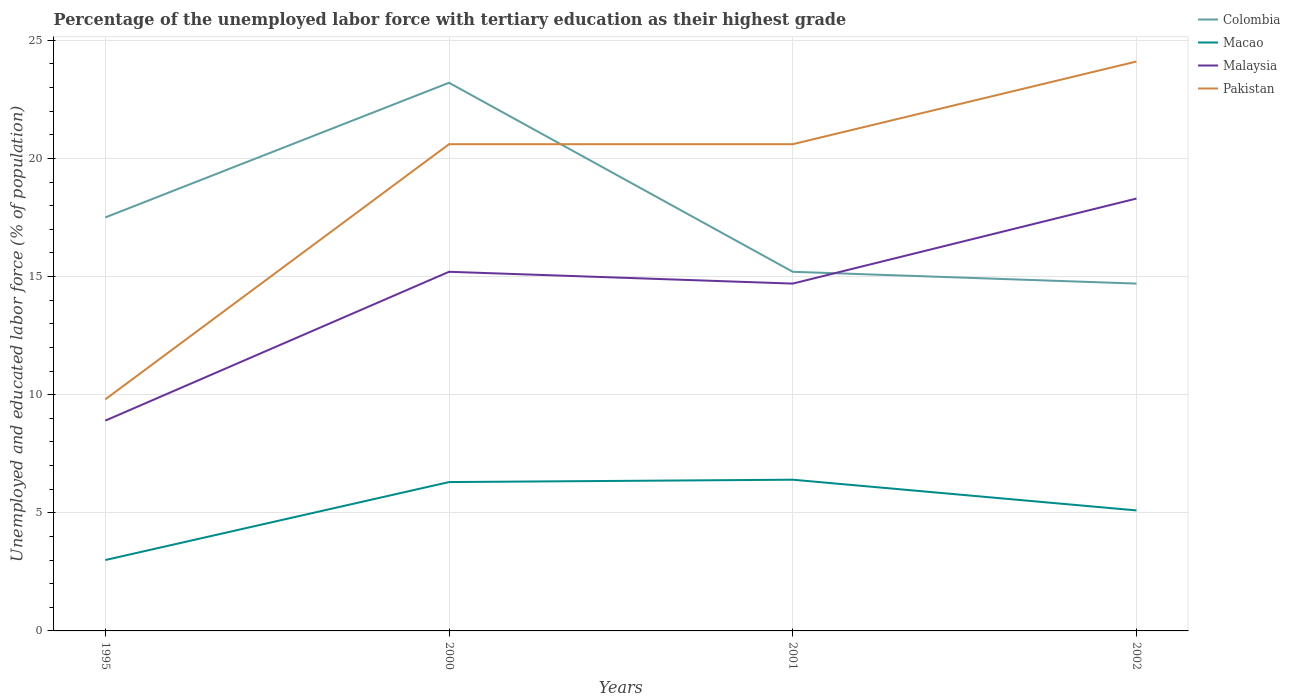Is the number of lines equal to the number of legend labels?
Your answer should be very brief. Yes. Across all years, what is the maximum percentage of the unemployed labor force with tertiary education in Pakistan?
Your response must be concise. 9.8. In which year was the percentage of the unemployed labor force with tertiary education in Macao maximum?
Provide a succinct answer. 1995. What is the total percentage of the unemployed labor force with tertiary education in Colombia in the graph?
Keep it short and to the point. 2.8. What is the difference between the highest and the second highest percentage of the unemployed labor force with tertiary education in Macao?
Ensure brevity in your answer.  3.4. What is the difference between the highest and the lowest percentage of the unemployed labor force with tertiary education in Macao?
Give a very brief answer. 2. Is the percentage of the unemployed labor force with tertiary education in Malaysia strictly greater than the percentage of the unemployed labor force with tertiary education in Macao over the years?
Give a very brief answer. No. How many years are there in the graph?
Your answer should be very brief. 4. What is the difference between two consecutive major ticks on the Y-axis?
Keep it short and to the point. 5. Does the graph contain grids?
Make the answer very short. Yes. How many legend labels are there?
Keep it short and to the point. 4. How are the legend labels stacked?
Your answer should be very brief. Vertical. What is the title of the graph?
Provide a short and direct response. Percentage of the unemployed labor force with tertiary education as their highest grade. Does "Seychelles" appear as one of the legend labels in the graph?
Offer a terse response. No. What is the label or title of the X-axis?
Ensure brevity in your answer.  Years. What is the label or title of the Y-axis?
Your answer should be very brief. Unemployed and educated labor force (% of population). What is the Unemployed and educated labor force (% of population) in Colombia in 1995?
Offer a very short reply. 17.5. What is the Unemployed and educated labor force (% of population) of Malaysia in 1995?
Give a very brief answer. 8.9. What is the Unemployed and educated labor force (% of population) of Pakistan in 1995?
Offer a very short reply. 9.8. What is the Unemployed and educated labor force (% of population) of Colombia in 2000?
Make the answer very short. 23.2. What is the Unemployed and educated labor force (% of population) in Macao in 2000?
Offer a terse response. 6.3. What is the Unemployed and educated labor force (% of population) of Malaysia in 2000?
Your answer should be very brief. 15.2. What is the Unemployed and educated labor force (% of population) of Pakistan in 2000?
Keep it short and to the point. 20.6. What is the Unemployed and educated labor force (% of population) of Colombia in 2001?
Keep it short and to the point. 15.2. What is the Unemployed and educated labor force (% of population) of Macao in 2001?
Offer a very short reply. 6.4. What is the Unemployed and educated labor force (% of population) of Malaysia in 2001?
Provide a short and direct response. 14.7. What is the Unemployed and educated labor force (% of population) of Pakistan in 2001?
Keep it short and to the point. 20.6. What is the Unemployed and educated labor force (% of population) of Colombia in 2002?
Ensure brevity in your answer.  14.7. What is the Unemployed and educated labor force (% of population) in Macao in 2002?
Give a very brief answer. 5.1. What is the Unemployed and educated labor force (% of population) in Malaysia in 2002?
Provide a short and direct response. 18.3. What is the Unemployed and educated labor force (% of population) of Pakistan in 2002?
Your answer should be compact. 24.1. Across all years, what is the maximum Unemployed and educated labor force (% of population) of Colombia?
Your answer should be very brief. 23.2. Across all years, what is the maximum Unemployed and educated labor force (% of population) in Macao?
Offer a very short reply. 6.4. Across all years, what is the maximum Unemployed and educated labor force (% of population) of Malaysia?
Offer a terse response. 18.3. Across all years, what is the maximum Unemployed and educated labor force (% of population) in Pakistan?
Give a very brief answer. 24.1. Across all years, what is the minimum Unemployed and educated labor force (% of population) in Colombia?
Your answer should be compact. 14.7. Across all years, what is the minimum Unemployed and educated labor force (% of population) of Macao?
Your answer should be compact. 3. Across all years, what is the minimum Unemployed and educated labor force (% of population) of Malaysia?
Ensure brevity in your answer.  8.9. Across all years, what is the minimum Unemployed and educated labor force (% of population) of Pakistan?
Your answer should be very brief. 9.8. What is the total Unemployed and educated labor force (% of population) of Colombia in the graph?
Offer a terse response. 70.6. What is the total Unemployed and educated labor force (% of population) of Macao in the graph?
Offer a terse response. 20.8. What is the total Unemployed and educated labor force (% of population) of Malaysia in the graph?
Your answer should be very brief. 57.1. What is the total Unemployed and educated labor force (% of population) in Pakistan in the graph?
Your response must be concise. 75.1. What is the difference between the Unemployed and educated labor force (% of population) of Malaysia in 1995 and that in 2001?
Your response must be concise. -5.8. What is the difference between the Unemployed and educated labor force (% of population) in Pakistan in 1995 and that in 2001?
Give a very brief answer. -10.8. What is the difference between the Unemployed and educated labor force (% of population) in Colombia in 1995 and that in 2002?
Offer a terse response. 2.8. What is the difference between the Unemployed and educated labor force (% of population) of Pakistan in 1995 and that in 2002?
Keep it short and to the point. -14.3. What is the difference between the Unemployed and educated labor force (% of population) in Colombia in 2000 and that in 2001?
Your response must be concise. 8. What is the difference between the Unemployed and educated labor force (% of population) of Malaysia in 2000 and that in 2002?
Make the answer very short. -3.1. What is the difference between the Unemployed and educated labor force (% of population) in Pakistan in 2000 and that in 2002?
Provide a short and direct response. -3.5. What is the difference between the Unemployed and educated labor force (% of population) of Colombia in 1995 and the Unemployed and educated labor force (% of population) of Macao in 2000?
Make the answer very short. 11.2. What is the difference between the Unemployed and educated labor force (% of population) of Colombia in 1995 and the Unemployed and educated labor force (% of population) of Pakistan in 2000?
Your answer should be very brief. -3.1. What is the difference between the Unemployed and educated labor force (% of population) in Macao in 1995 and the Unemployed and educated labor force (% of population) in Pakistan in 2000?
Offer a terse response. -17.6. What is the difference between the Unemployed and educated labor force (% of population) of Colombia in 1995 and the Unemployed and educated labor force (% of population) of Malaysia in 2001?
Give a very brief answer. 2.8. What is the difference between the Unemployed and educated labor force (% of population) in Macao in 1995 and the Unemployed and educated labor force (% of population) in Malaysia in 2001?
Your answer should be compact. -11.7. What is the difference between the Unemployed and educated labor force (% of population) in Macao in 1995 and the Unemployed and educated labor force (% of population) in Pakistan in 2001?
Your answer should be very brief. -17.6. What is the difference between the Unemployed and educated labor force (% of population) in Malaysia in 1995 and the Unemployed and educated labor force (% of population) in Pakistan in 2001?
Ensure brevity in your answer.  -11.7. What is the difference between the Unemployed and educated labor force (% of population) of Colombia in 1995 and the Unemployed and educated labor force (% of population) of Malaysia in 2002?
Your response must be concise. -0.8. What is the difference between the Unemployed and educated labor force (% of population) in Colombia in 1995 and the Unemployed and educated labor force (% of population) in Pakistan in 2002?
Your answer should be compact. -6.6. What is the difference between the Unemployed and educated labor force (% of population) of Macao in 1995 and the Unemployed and educated labor force (% of population) of Malaysia in 2002?
Keep it short and to the point. -15.3. What is the difference between the Unemployed and educated labor force (% of population) of Macao in 1995 and the Unemployed and educated labor force (% of population) of Pakistan in 2002?
Provide a short and direct response. -21.1. What is the difference between the Unemployed and educated labor force (% of population) of Malaysia in 1995 and the Unemployed and educated labor force (% of population) of Pakistan in 2002?
Keep it short and to the point. -15.2. What is the difference between the Unemployed and educated labor force (% of population) of Macao in 2000 and the Unemployed and educated labor force (% of population) of Pakistan in 2001?
Your answer should be very brief. -14.3. What is the difference between the Unemployed and educated labor force (% of population) of Colombia in 2000 and the Unemployed and educated labor force (% of population) of Pakistan in 2002?
Your answer should be very brief. -0.9. What is the difference between the Unemployed and educated labor force (% of population) of Macao in 2000 and the Unemployed and educated labor force (% of population) of Malaysia in 2002?
Your answer should be compact. -12. What is the difference between the Unemployed and educated labor force (% of population) in Macao in 2000 and the Unemployed and educated labor force (% of population) in Pakistan in 2002?
Offer a terse response. -17.8. What is the difference between the Unemployed and educated labor force (% of population) of Colombia in 2001 and the Unemployed and educated labor force (% of population) of Pakistan in 2002?
Your response must be concise. -8.9. What is the difference between the Unemployed and educated labor force (% of population) of Macao in 2001 and the Unemployed and educated labor force (% of population) of Pakistan in 2002?
Give a very brief answer. -17.7. What is the average Unemployed and educated labor force (% of population) in Colombia per year?
Offer a very short reply. 17.65. What is the average Unemployed and educated labor force (% of population) of Malaysia per year?
Offer a very short reply. 14.28. What is the average Unemployed and educated labor force (% of population) of Pakistan per year?
Provide a short and direct response. 18.77. In the year 1995, what is the difference between the Unemployed and educated labor force (% of population) in Colombia and Unemployed and educated labor force (% of population) in Macao?
Give a very brief answer. 14.5. In the year 1995, what is the difference between the Unemployed and educated labor force (% of population) in Macao and Unemployed and educated labor force (% of population) in Malaysia?
Give a very brief answer. -5.9. In the year 1995, what is the difference between the Unemployed and educated labor force (% of population) in Malaysia and Unemployed and educated labor force (% of population) in Pakistan?
Make the answer very short. -0.9. In the year 2000, what is the difference between the Unemployed and educated labor force (% of population) in Colombia and Unemployed and educated labor force (% of population) in Malaysia?
Ensure brevity in your answer.  8. In the year 2000, what is the difference between the Unemployed and educated labor force (% of population) in Macao and Unemployed and educated labor force (% of population) in Pakistan?
Provide a short and direct response. -14.3. In the year 2000, what is the difference between the Unemployed and educated labor force (% of population) in Malaysia and Unemployed and educated labor force (% of population) in Pakistan?
Your answer should be very brief. -5.4. In the year 2001, what is the difference between the Unemployed and educated labor force (% of population) of Colombia and Unemployed and educated labor force (% of population) of Macao?
Provide a short and direct response. 8.8. In the year 2001, what is the difference between the Unemployed and educated labor force (% of population) of Colombia and Unemployed and educated labor force (% of population) of Pakistan?
Your answer should be very brief. -5.4. In the year 2001, what is the difference between the Unemployed and educated labor force (% of population) in Macao and Unemployed and educated labor force (% of population) in Pakistan?
Provide a succinct answer. -14.2. In the year 2001, what is the difference between the Unemployed and educated labor force (% of population) in Malaysia and Unemployed and educated labor force (% of population) in Pakistan?
Ensure brevity in your answer.  -5.9. In the year 2002, what is the difference between the Unemployed and educated labor force (% of population) in Colombia and Unemployed and educated labor force (% of population) in Macao?
Ensure brevity in your answer.  9.6. In the year 2002, what is the difference between the Unemployed and educated labor force (% of population) in Colombia and Unemployed and educated labor force (% of population) in Malaysia?
Your answer should be compact. -3.6. In the year 2002, what is the difference between the Unemployed and educated labor force (% of population) in Malaysia and Unemployed and educated labor force (% of population) in Pakistan?
Your response must be concise. -5.8. What is the ratio of the Unemployed and educated labor force (% of population) in Colombia in 1995 to that in 2000?
Provide a short and direct response. 0.75. What is the ratio of the Unemployed and educated labor force (% of population) of Macao in 1995 to that in 2000?
Keep it short and to the point. 0.48. What is the ratio of the Unemployed and educated labor force (% of population) of Malaysia in 1995 to that in 2000?
Offer a terse response. 0.59. What is the ratio of the Unemployed and educated labor force (% of population) in Pakistan in 1995 to that in 2000?
Make the answer very short. 0.48. What is the ratio of the Unemployed and educated labor force (% of population) of Colombia in 1995 to that in 2001?
Ensure brevity in your answer.  1.15. What is the ratio of the Unemployed and educated labor force (% of population) of Macao in 1995 to that in 2001?
Make the answer very short. 0.47. What is the ratio of the Unemployed and educated labor force (% of population) of Malaysia in 1995 to that in 2001?
Your answer should be very brief. 0.61. What is the ratio of the Unemployed and educated labor force (% of population) in Pakistan in 1995 to that in 2001?
Keep it short and to the point. 0.48. What is the ratio of the Unemployed and educated labor force (% of population) of Colombia in 1995 to that in 2002?
Ensure brevity in your answer.  1.19. What is the ratio of the Unemployed and educated labor force (% of population) of Macao in 1995 to that in 2002?
Offer a very short reply. 0.59. What is the ratio of the Unemployed and educated labor force (% of population) in Malaysia in 1995 to that in 2002?
Keep it short and to the point. 0.49. What is the ratio of the Unemployed and educated labor force (% of population) in Pakistan in 1995 to that in 2002?
Provide a short and direct response. 0.41. What is the ratio of the Unemployed and educated labor force (% of population) of Colombia in 2000 to that in 2001?
Make the answer very short. 1.53. What is the ratio of the Unemployed and educated labor force (% of population) in Macao in 2000 to that in 2001?
Make the answer very short. 0.98. What is the ratio of the Unemployed and educated labor force (% of population) in Malaysia in 2000 to that in 2001?
Provide a short and direct response. 1.03. What is the ratio of the Unemployed and educated labor force (% of population) in Pakistan in 2000 to that in 2001?
Offer a terse response. 1. What is the ratio of the Unemployed and educated labor force (% of population) of Colombia in 2000 to that in 2002?
Make the answer very short. 1.58. What is the ratio of the Unemployed and educated labor force (% of population) of Macao in 2000 to that in 2002?
Provide a short and direct response. 1.24. What is the ratio of the Unemployed and educated labor force (% of population) in Malaysia in 2000 to that in 2002?
Your response must be concise. 0.83. What is the ratio of the Unemployed and educated labor force (% of population) of Pakistan in 2000 to that in 2002?
Your answer should be very brief. 0.85. What is the ratio of the Unemployed and educated labor force (% of population) in Colombia in 2001 to that in 2002?
Ensure brevity in your answer.  1.03. What is the ratio of the Unemployed and educated labor force (% of population) in Macao in 2001 to that in 2002?
Your response must be concise. 1.25. What is the ratio of the Unemployed and educated labor force (% of population) of Malaysia in 2001 to that in 2002?
Offer a terse response. 0.8. What is the ratio of the Unemployed and educated labor force (% of population) of Pakistan in 2001 to that in 2002?
Provide a short and direct response. 0.85. What is the difference between the highest and the second highest Unemployed and educated labor force (% of population) in Pakistan?
Your response must be concise. 3.5. What is the difference between the highest and the lowest Unemployed and educated labor force (% of population) of Colombia?
Provide a succinct answer. 8.5. What is the difference between the highest and the lowest Unemployed and educated labor force (% of population) of Macao?
Your response must be concise. 3.4. What is the difference between the highest and the lowest Unemployed and educated labor force (% of population) in Malaysia?
Make the answer very short. 9.4. 